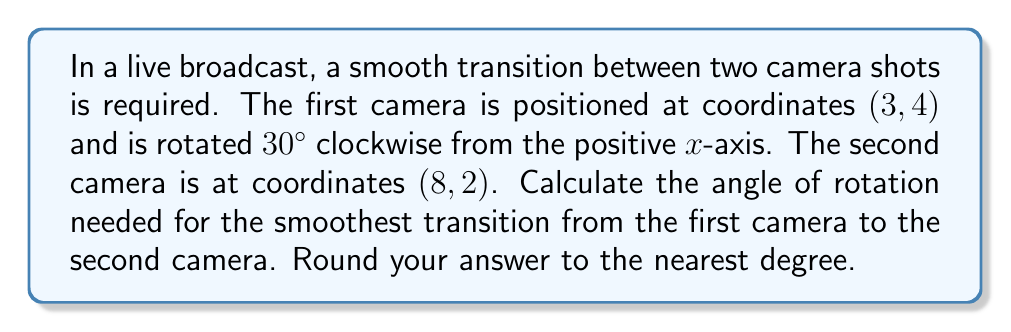Show me your answer to this math problem. To find the angle of rotation for a smooth transition, we need to follow these steps:

1) First, let's visualize the problem:

[asy]
import geometry;

unitsize(1cm);

pair A = (3,4);
pair B = (8,2);

draw((-1,0)--(10,0), arrow=Arrow(TeXHead));
draw((0,-1)--(0,6), arrow=Arrow(TeXHead));

dot("A (3,4)", A, NW);
dot("B (8,2)", B, SE);

draw(A--B, dashed);

real angle1 = 30 * pi / 180;
draw(A--(A + (cos(angle1), sin(angle1))), arrow=Arrow(TeXHead));

label("x", (10,0), E);
label("y", (0,6), N);

label("30°", A+(0.7,0.3), NE);
[/asy]

2) We need to find the angle between the line AB and the positive x-axis. This angle minus 30° will give us the required rotation.

3) To find the angle of line AB with the x-axis, we can use the arctangent function:

   $$\theta = \arctan(\frac{y_2 - y_1}{x_2 - x_1})$$

   Where $(x_1, y_1)$ is (3, 4) and $(x_2, y_2)$ is (8, 2).

4) Let's calculate:

   $$\theta = \arctan(\frac{2 - 4}{8 - 3}) = \arctan(\frac{-2}{5})$$

5) Using a calculator or computer:

   $$\theta \approx -21.80°$$

6) However, this is the angle from the positive x-axis to the line pointing from A to B. We need the angle from B to A, which is 180° more:

   $$\theta_{BA} = -21.80° + 180° = 158.20°$$

7) Now, to get the required rotation, we subtract the initial 30° rotation of the first camera:

   $$\text{Required rotation} = 158.20° - 30° = 128.20°$$

8) Rounding to the nearest degree:

   $$\text{Required rotation} \approx 128°$$
Answer: 128° 